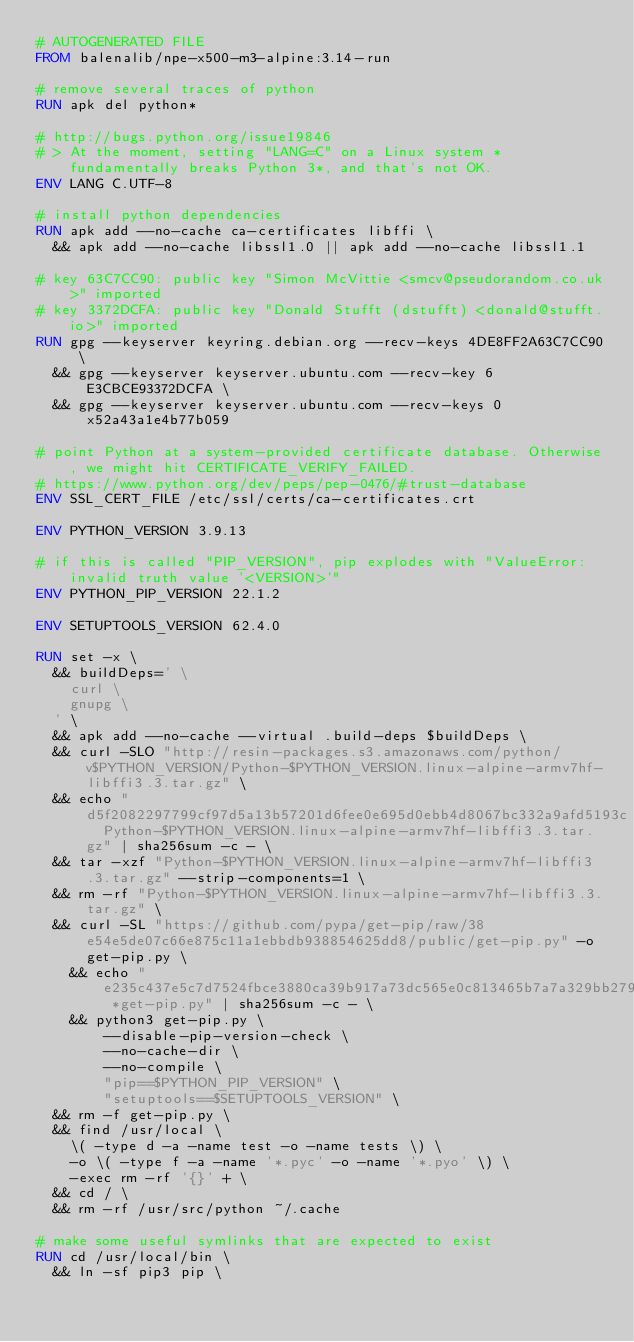Convert code to text. <code><loc_0><loc_0><loc_500><loc_500><_Dockerfile_># AUTOGENERATED FILE
FROM balenalib/npe-x500-m3-alpine:3.14-run

# remove several traces of python
RUN apk del python*

# http://bugs.python.org/issue19846
# > At the moment, setting "LANG=C" on a Linux system *fundamentally breaks Python 3*, and that's not OK.
ENV LANG C.UTF-8

# install python dependencies
RUN apk add --no-cache ca-certificates libffi \
	&& apk add --no-cache libssl1.0 || apk add --no-cache libssl1.1

# key 63C7CC90: public key "Simon McVittie <smcv@pseudorandom.co.uk>" imported
# key 3372DCFA: public key "Donald Stufft (dstufft) <donald@stufft.io>" imported
RUN gpg --keyserver keyring.debian.org --recv-keys 4DE8FF2A63C7CC90 \
	&& gpg --keyserver keyserver.ubuntu.com --recv-key 6E3CBCE93372DCFA \
	&& gpg --keyserver keyserver.ubuntu.com --recv-keys 0x52a43a1e4b77b059

# point Python at a system-provided certificate database. Otherwise, we might hit CERTIFICATE_VERIFY_FAILED.
# https://www.python.org/dev/peps/pep-0476/#trust-database
ENV SSL_CERT_FILE /etc/ssl/certs/ca-certificates.crt

ENV PYTHON_VERSION 3.9.13

# if this is called "PIP_VERSION", pip explodes with "ValueError: invalid truth value '<VERSION>'"
ENV PYTHON_PIP_VERSION 22.1.2

ENV SETUPTOOLS_VERSION 62.4.0

RUN set -x \
	&& buildDeps=' \
		curl \
		gnupg \
	' \
	&& apk add --no-cache --virtual .build-deps $buildDeps \
	&& curl -SLO "http://resin-packages.s3.amazonaws.com/python/v$PYTHON_VERSION/Python-$PYTHON_VERSION.linux-alpine-armv7hf-libffi3.3.tar.gz" \
	&& echo "d5f2082297799cf97d5a13b57201d6fee0e695d0ebb4d8067bc332a9afd5193c  Python-$PYTHON_VERSION.linux-alpine-armv7hf-libffi3.3.tar.gz" | sha256sum -c - \
	&& tar -xzf "Python-$PYTHON_VERSION.linux-alpine-armv7hf-libffi3.3.tar.gz" --strip-components=1 \
	&& rm -rf "Python-$PYTHON_VERSION.linux-alpine-armv7hf-libffi3.3.tar.gz" \
	&& curl -SL "https://github.com/pypa/get-pip/raw/38e54e5de07c66e875c11a1ebbdb938854625dd8/public/get-pip.py" -o get-pip.py \
    && echo "e235c437e5c7d7524fbce3880ca39b917a73dc565e0c813465b7a7a329bb279a *get-pip.py" | sha256sum -c - \
    && python3 get-pip.py \
        --disable-pip-version-check \
        --no-cache-dir \
        --no-compile \
        "pip==$PYTHON_PIP_VERSION" \
        "setuptools==$SETUPTOOLS_VERSION" \
	&& rm -f get-pip.py \
	&& find /usr/local \
		\( -type d -a -name test -o -name tests \) \
		-o \( -type f -a -name '*.pyc' -o -name '*.pyo' \) \
		-exec rm -rf '{}' + \
	&& cd / \
	&& rm -rf /usr/src/python ~/.cache

# make some useful symlinks that are expected to exist
RUN cd /usr/local/bin \
	&& ln -sf pip3 pip \</code> 